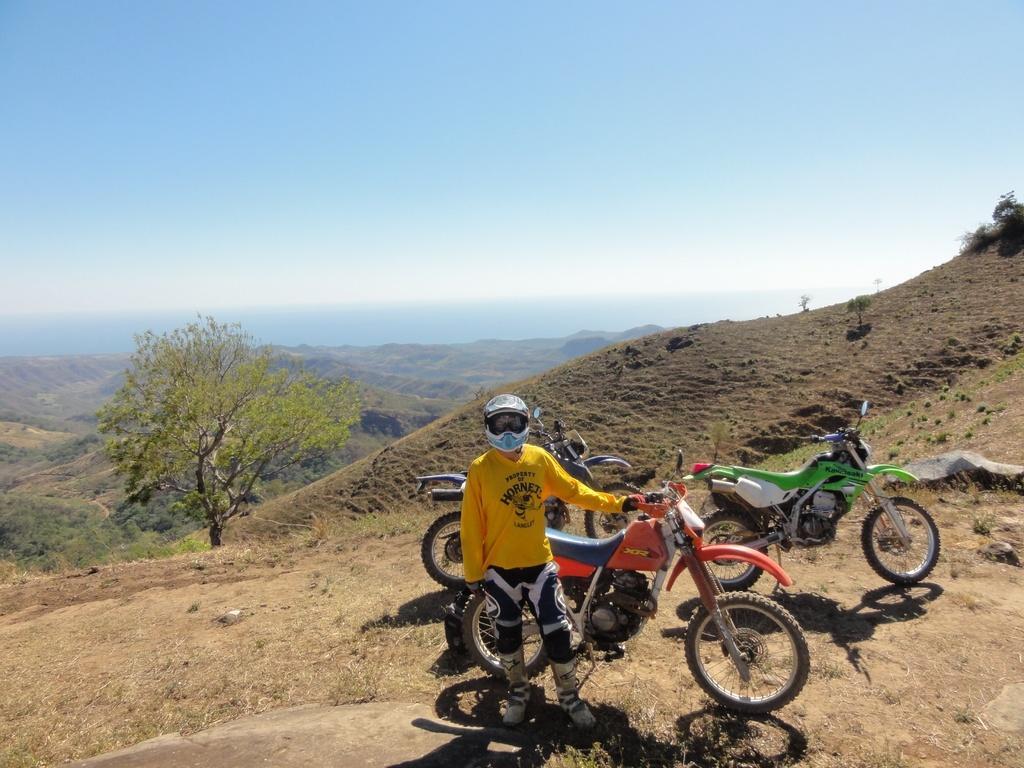Can you describe this image briefly? This is an outside view. Here I can see few motorcycles on the ground and one person is wearing helmet on the head, standing and giving pose for the picture. On the left side there is a tree. In the background there are few hills. At the top of the image, I can see the sky. 